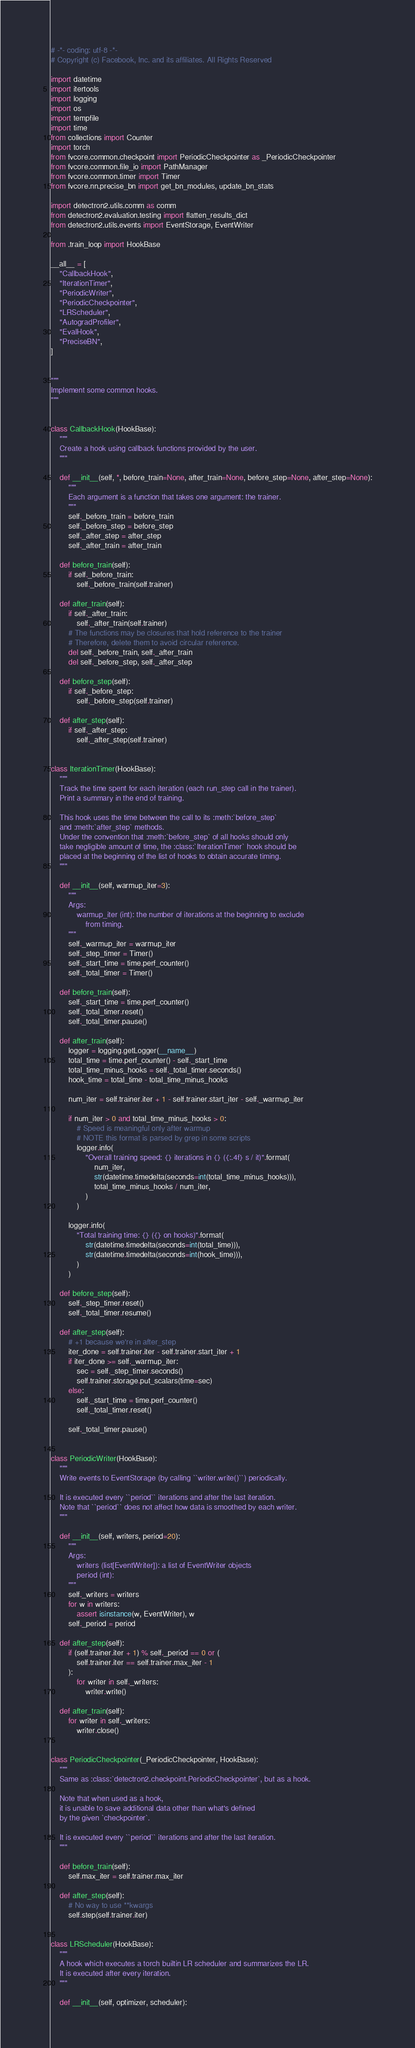Convert code to text. <code><loc_0><loc_0><loc_500><loc_500><_Python_># -*- coding: utf-8 -*-
# Copyright (c) Facebook, Inc. and its affiliates. All Rights Reserved

import datetime
import itertools
import logging
import os
import tempfile
import time
from collections import Counter
import torch
from fvcore.common.checkpoint import PeriodicCheckpointer as _PeriodicCheckpointer
from fvcore.common.file_io import PathManager
from fvcore.common.timer import Timer
from fvcore.nn.precise_bn import get_bn_modules, update_bn_stats

import detectron2.utils.comm as comm
from detectron2.evaluation.testing import flatten_results_dict
from detectron2.utils.events import EventStorage, EventWriter

from .train_loop import HookBase

__all__ = [
    "CallbackHook",
    "IterationTimer",
    "PeriodicWriter",
    "PeriodicCheckpointer",
    "LRScheduler",
    "AutogradProfiler",
    "EvalHook",
    "PreciseBN",
]


"""
Implement some common hooks.
"""


class CallbackHook(HookBase):
    """
    Create a hook using callback functions provided by the user.
    """

    def __init__(self, *, before_train=None, after_train=None, before_step=None, after_step=None):
        """
        Each argument is a function that takes one argument: the trainer.
        """
        self._before_train = before_train
        self._before_step = before_step
        self._after_step = after_step
        self._after_train = after_train

    def before_train(self):
        if self._before_train:
            self._before_train(self.trainer)

    def after_train(self):
        if self._after_train:
            self._after_train(self.trainer)
        # The functions may be closures that hold reference to the trainer
        # Therefore, delete them to avoid circular reference.
        del self._before_train, self._after_train
        del self._before_step, self._after_step

    def before_step(self):
        if self._before_step:
            self._before_step(self.trainer)

    def after_step(self):
        if self._after_step:
            self._after_step(self.trainer)


class IterationTimer(HookBase):
    """
    Track the time spent for each iteration (each run_step call in the trainer).
    Print a summary in the end of training.

    This hook uses the time between the call to its :meth:`before_step`
    and :meth:`after_step` methods.
    Under the convention that :meth:`before_step` of all hooks should only
    take negligible amount of time, the :class:`IterationTimer` hook should be
    placed at the beginning of the list of hooks to obtain accurate timing.
    """

    def __init__(self, warmup_iter=3):
        """
        Args:
            warmup_iter (int): the number of iterations at the beginning to exclude
                from timing.
        """
        self._warmup_iter = warmup_iter
        self._step_timer = Timer()
        self._start_time = time.perf_counter()
        self._total_timer = Timer()

    def before_train(self):
        self._start_time = time.perf_counter()
        self._total_timer.reset()
        self._total_timer.pause()

    def after_train(self):
        logger = logging.getLogger(__name__)
        total_time = time.perf_counter() - self._start_time
        total_time_minus_hooks = self._total_timer.seconds()
        hook_time = total_time - total_time_minus_hooks

        num_iter = self.trainer.iter + 1 - self.trainer.start_iter - self._warmup_iter

        if num_iter > 0 and total_time_minus_hooks > 0:
            # Speed is meaningful only after warmup
            # NOTE this format is parsed by grep in some scripts
            logger.info(
                "Overall training speed: {} iterations in {} ({:.4f} s / it)".format(
                    num_iter,
                    str(datetime.timedelta(seconds=int(total_time_minus_hooks))),
                    total_time_minus_hooks / num_iter,
                )
            )

        logger.info(
            "Total training time: {} ({} on hooks)".format(
                str(datetime.timedelta(seconds=int(total_time))),
                str(datetime.timedelta(seconds=int(hook_time))),
            )
        )

    def before_step(self):
        self._step_timer.reset()
        self._total_timer.resume()

    def after_step(self):
        # +1 because we're in after_step
        iter_done = self.trainer.iter - self.trainer.start_iter + 1
        if iter_done >= self._warmup_iter:
            sec = self._step_timer.seconds()
            self.trainer.storage.put_scalars(time=sec)
        else:
            self._start_time = time.perf_counter()
            self._total_timer.reset()

        self._total_timer.pause()


class PeriodicWriter(HookBase):
    """
    Write events to EventStorage (by calling ``writer.write()``) periodically.

    It is executed every ``period`` iterations and after the last iteration.
    Note that ``period`` does not affect how data is smoothed by each writer.
    """

    def __init__(self, writers, period=20):
        """
        Args:
            writers (list[EventWriter]): a list of EventWriter objects
            period (int):
        """
        self._writers = writers
        for w in writers:
            assert isinstance(w, EventWriter), w
        self._period = period

    def after_step(self):
        if (self.trainer.iter + 1) % self._period == 0 or (
            self.trainer.iter == self.trainer.max_iter - 1
        ):
            for writer in self._writers:
                writer.write()

    def after_train(self):
        for writer in self._writers:
            writer.close()


class PeriodicCheckpointer(_PeriodicCheckpointer, HookBase):
    """
    Same as :class:`detectron2.checkpoint.PeriodicCheckpointer`, but as a hook.

    Note that when used as a hook,
    it is unable to save additional data other than what's defined
    by the given `checkpointer`.

    It is executed every ``period`` iterations and after the last iteration.
    """

    def before_train(self):
        self.max_iter = self.trainer.max_iter

    def after_step(self):
        # No way to use **kwargs
        self.step(self.trainer.iter)


class LRScheduler(HookBase):
    """
    A hook which executes a torch builtin LR scheduler and summarizes the LR.
    It is executed after every iteration.
    """

    def __init__(self, optimizer, scheduler):</code> 